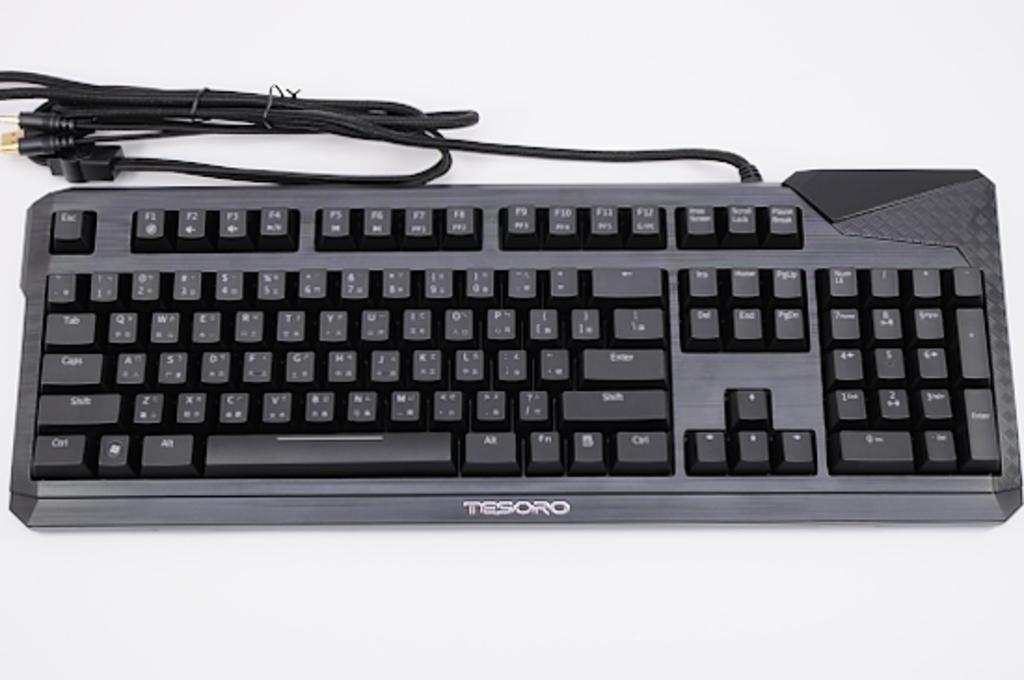What is the main object in the image? There is a keyboard in the image. Where is the keyboard located? The keyboard is placed on a table. How much tax is being paid on the keyboard in the image? There is no indication of tax being paid on the keyboard in the image, as it is an object and not a purchase. 